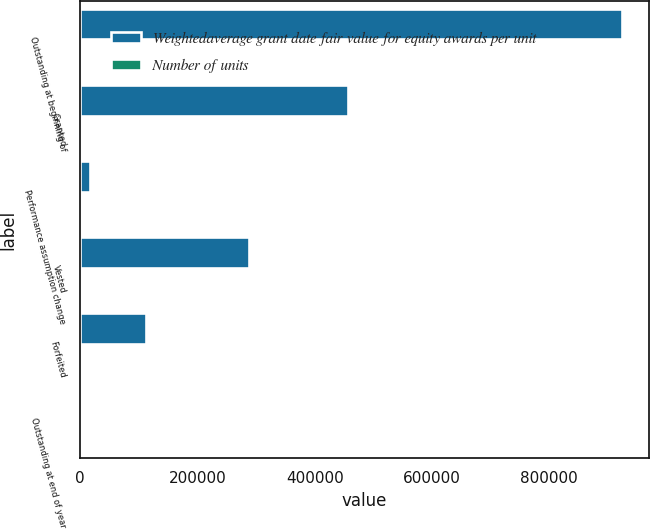Convert chart to OTSL. <chart><loc_0><loc_0><loc_500><loc_500><stacked_bar_chart><ecel><fcel>Outstanding at beginning of<fcel>Granted<fcel>Performance assumption change<fcel>Vested<fcel>Forfeited<fcel>Outstanding at end of year<nl><fcel>Weightedaverage grant date fair value for equity awards per unit<fcel>923364<fcel>457315<fcel>16961<fcel>287101<fcel>111521<fcel>103.59<nl><fcel>Number of units<fcel>103.11<fcel>97.86<fcel>102.71<fcel>103.59<fcel>103.48<fcel>101.57<nl></chart> 